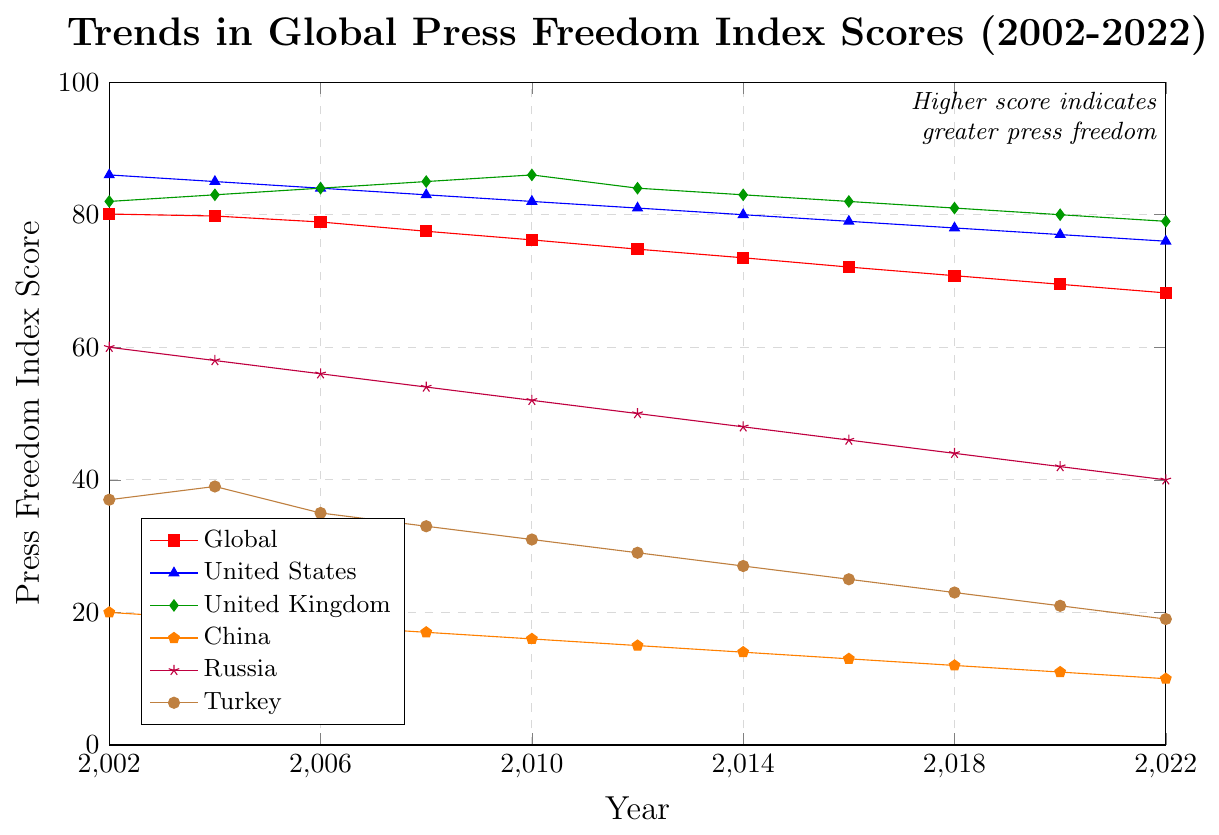What is the overall trend in the Global Press Freedom Index Score from 2002 to 2022? The Global Press Freedom Index Score has been decreasing over the two decades, from 80.1 in 2002 to 68.2 in 2022. This indicates a decline in global press freedom over the past two decades.
Answer: Declining Which country had the highest Press Freedom Index Score in 2002? By examining the chart, the United States had the highest score of 86 in 2002.
Answer: United States Between which years did the United Kingdom's Press Freedom Index Score remain the same? The UK’s score remained the same between 2008 and 2010, both at 86.
Answer: 2008-2010 Compare the trends in press freedom scores for the United States and China from 2002 to 2022. The United States' score steadily decreased from 86 to 76, showing a slight decline, while China's score decreased from 20 to 10, which indicates a more consistent and significant decline in press freedom.
Answer: Both decreased, but China's decline is more significant What is the average Press Freedom Index Score for Turkey over the observed period? The scores for Turkey are: 37, 39, 35, 33, 31, 29, 27, 25, 23, 21, 19. Summing these gives 319. Dividing by the number of years (11) gives an average score of 29.
Answer: 29 In which year did Russia have a Press Freedom Index Score of 50? According to the chart, Russia had a score of 50 in the year 2012.
Answer: 2012 By how much did the Global Press Freedom Index Score change from 2002 to 2022? The Global Press Freedom Index Score decreased from 80.1 in 2002 to 68.2 in 2022. The change is calculated as 80.1 - 68.2 = 11.9.
Answer: 11.9 Which country saw the smallest change in its Press Freedom Index Score from 2002 to 2022? By observing the changes from 2002 to 2022 for each country: 
- United States: 86 - 76 = 10 
- United Kingdom: 82 - 79 = 3 
- China: 20 - 10 = 10 
- Russia: 60 - 40 = 20 
- Turkey: 37 - 19 = 18 
Thus, the UK saw the smallest change with a reduction of 3.
Answer: United Kingdom In what year did the United States' Press Freedom Index Score drop below 80? According to the chart, the score dropped below 80 in the year 2016 when it was 79.
Answer: 2016 